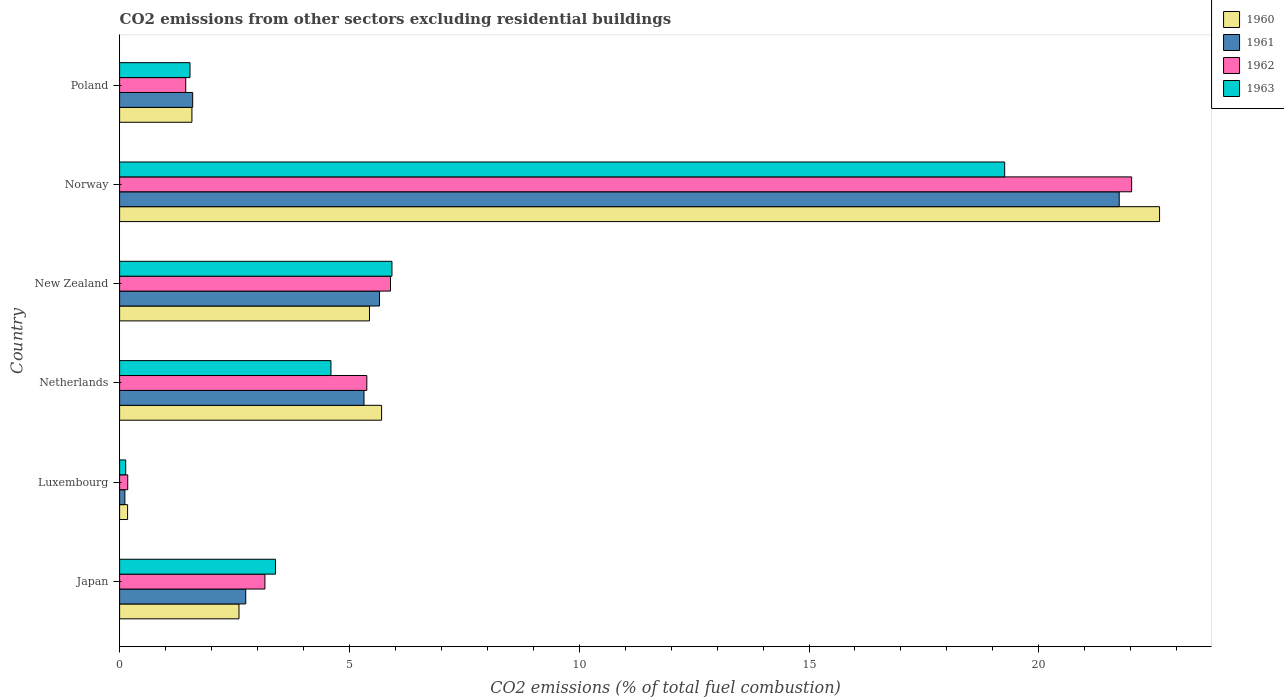Are the number of bars per tick equal to the number of legend labels?
Keep it short and to the point. Yes. How many bars are there on the 3rd tick from the bottom?
Your answer should be very brief. 4. What is the label of the 3rd group of bars from the top?
Ensure brevity in your answer.  New Zealand. What is the total CO2 emitted in 1962 in Japan?
Provide a succinct answer. 3.16. Across all countries, what is the maximum total CO2 emitted in 1963?
Your answer should be compact. 19.26. Across all countries, what is the minimum total CO2 emitted in 1960?
Give a very brief answer. 0.17. In which country was the total CO2 emitted in 1961 minimum?
Make the answer very short. Luxembourg. What is the total total CO2 emitted in 1963 in the graph?
Provide a succinct answer. 34.84. What is the difference between the total CO2 emitted in 1962 in New Zealand and that in Poland?
Make the answer very short. 4.45. What is the difference between the total CO2 emitted in 1961 in Poland and the total CO2 emitted in 1960 in Norway?
Offer a very short reply. -21.04. What is the average total CO2 emitted in 1961 per country?
Provide a succinct answer. 6.2. What is the difference between the total CO2 emitted in 1962 and total CO2 emitted in 1961 in Netherlands?
Offer a very short reply. 0.06. What is the ratio of the total CO2 emitted in 1963 in Japan to that in Netherlands?
Ensure brevity in your answer.  0.74. What is the difference between the highest and the second highest total CO2 emitted in 1962?
Provide a succinct answer. 16.13. What is the difference between the highest and the lowest total CO2 emitted in 1963?
Make the answer very short. 19.12. Is it the case that in every country, the sum of the total CO2 emitted in 1962 and total CO2 emitted in 1961 is greater than the sum of total CO2 emitted in 1960 and total CO2 emitted in 1963?
Give a very brief answer. No. What does the 4th bar from the top in Japan represents?
Keep it short and to the point. 1960. What does the 1st bar from the bottom in Norway represents?
Your answer should be compact. 1960. Is it the case that in every country, the sum of the total CO2 emitted in 1960 and total CO2 emitted in 1962 is greater than the total CO2 emitted in 1963?
Give a very brief answer. Yes. Are all the bars in the graph horizontal?
Provide a succinct answer. Yes. How many countries are there in the graph?
Offer a terse response. 6. What is the difference between two consecutive major ticks on the X-axis?
Offer a very short reply. 5. Does the graph contain any zero values?
Provide a short and direct response. No. How many legend labels are there?
Keep it short and to the point. 4. What is the title of the graph?
Offer a very short reply. CO2 emissions from other sectors excluding residential buildings. Does "1976" appear as one of the legend labels in the graph?
Make the answer very short. No. What is the label or title of the X-axis?
Keep it short and to the point. CO2 emissions (% of total fuel combustion). What is the label or title of the Y-axis?
Give a very brief answer. Country. What is the CO2 emissions (% of total fuel combustion) of 1960 in Japan?
Offer a terse response. 2.6. What is the CO2 emissions (% of total fuel combustion) in 1961 in Japan?
Keep it short and to the point. 2.74. What is the CO2 emissions (% of total fuel combustion) in 1962 in Japan?
Provide a short and direct response. 3.16. What is the CO2 emissions (% of total fuel combustion) in 1963 in Japan?
Make the answer very short. 3.39. What is the CO2 emissions (% of total fuel combustion) in 1960 in Luxembourg?
Provide a succinct answer. 0.17. What is the CO2 emissions (% of total fuel combustion) in 1961 in Luxembourg?
Offer a terse response. 0.11. What is the CO2 emissions (% of total fuel combustion) of 1962 in Luxembourg?
Offer a terse response. 0.18. What is the CO2 emissions (% of total fuel combustion) in 1963 in Luxembourg?
Offer a terse response. 0.13. What is the CO2 emissions (% of total fuel combustion) in 1960 in Netherlands?
Provide a short and direct response. 5.7. What is the CO2 emissions (% of total fuel combustion) of 1961 in Netherlands?
Your answer should be compact. 5.32. What is the CO2 emissions (% of total fuel combustion) of 1962 in Netherlands?
Ensure brevity in your answer.  5.38. What is the CO2 emissions (% of total fuel combustion) of 1963 in Netherlands?
Ensure brevity in your answer.  4.6. What is the CO2 emissions (% of total fuel combustion) in 1960 in New Zealand?
Provide a succinct answer. 5.44. What is the CO2 emissions (% of total fuel combustion) in 1961 in New Zealand?
Offer a very short reply. 5.66. What is the CO2 emissions (% of total fuel combustion) of 1962 in New Zealand?
Provide a succinct answer. 5.89. What is the CO2 emissions (% of total fuel combustion) in 1963 in New Zealand?
Give a very brief answer. 5.93. What is the CO2 emissions (% of total fuel combustion) of 1960 in Norway?
Give a very brief answer. 22.63. What is the CO2 emissions (% of total fuel combustion) of 1961 in Norway?
Provide a succinct answer. 21.75. What is the CO2 emissions (% of total fuel combustion) of 1962 in Norway?
Make the answer very short. 22.02. What is the CO2 emissions (% of total fuel combustion) in 1963 in Norway?
Your answer should be very brief. 19.26. What is the CO2 emissions (% of total fuel combustion) of 1960 in Poland?
Your answer should be compact. 1.57. What is the CO2 emissions (% of total fuel combustion) in 1961 in Poland?
Offer a very short reply. 1.59. What is the CO2 emissions (% of total fuel combustion) of 1962 in Poland?
Make the answer very short. 1.44. What is the CO2 emissions (% of total fuel combustion) in 1963 in Poland?
Provide a succinct answer. 1.53. Across all countries, what is the maximum CO2 emissions (% of total fuel combustion) of 1960?
Give a very brief answer. 22.63. Across all countries, what is the maximum CO2 emissions (% of total fuel combustion) of 1961?
Ensure brevity in your answer.  21.75. Across all countries, what is the maximum CO2 emissions (% of total fuel combustion) in 1962?
Ensure brevity in your answer.  22.02. Across all countries, what is the maximum CO2 emissions (% of total fuel combustion) of 1963?
Make the answer very short. 19.26. Across all countries, what is the minimum CO2 emissions (% of total fuel combustion) in 1960?
Offer a terse response. 0.17. Across all countries, what is the minimum CO2 emissions (% of total fuel combustion) in 1961?
Offer a very short reply. 0.11. Across all countries, what is the minimum CO2 emissions (% of total fuel combustion) of 1962?
Make the answer very short. 0.18. Across all countries, what is the minimum CO2 emissions (% of total fuel combustion) of 1963?
Your answer should be compact. 0.13. What is the total CO2 emissions (% of total fuel combustion) in 1960 in the graph?
Offer a terse response. 38.11. What is the total CO2 emissions (% of total fuel combustion) of 1961 in the graph?
Provide a succinct answer. 37.17. What is the total CO2 emissions (% of total fuel combustion) of 1962 in the graph?
Your answer should be very brief. 38.07. What is the total CO2 emissions (% of total fuel combustion) of 1963 in the graph?
Provide a succinct answer. 34.84. What is the difference between the CO2 emissions (% of total fuel combustion) of 1960 in Japan and that in Luxembourg?
Provide a succinct answer. 2.42. What is the difference between the CO2 emissions (% of total fuel combustion) of 1961 in Japan and that in Luxembourg?
Your answer should be compact. 2.63. What is the difference between the CO2 emissions (% of total fuel combustion) of 1962 in Japan and that in Luxembourg?
Provide a succinct answer. 2.98. What is the difference between the CO2 emissions (% of total fuel combustion) of 1963 in Japan and that in Luxembourg?
Provide a short and direct response. 3.26. What is the difference between the CO2 emissions (% of total fuel combustion) in 1960 in Japan and that in Netherlands?
Your response must be concise. -3.1. What is the difference between the CO2 emissions (% of total fuel combustion) of 1961 in Japan and that in Netherlands?
Make the answer very short. -2.57. What is the difference between the CO2 emissions (% of total fuel combustion) in 1962 in Japan and that in Netherlands?
Your response must be concise. -2.22. What is the difference between the CO2 emissions (% of total fuel combustion) in 1963 in Japan and that in Netherlands?
Your answer should be very brief. -1.21. What is the difference between the CO2 emissions (% of total fuel combustion) of 1960 in Japan and that in New Zealand?
Ensure brevity in your answer.  -2.84. What is the difference between the CO2 emissions (% of total fuel combustion) in 1961 in Japan and that in New Zealand?
Your answer should be very brief. -2.91. What is the difference between the CO2 emissions (% of total fuel combustion) in 1962 in Japan and that in New Zealand?
Provide a short and direct response. -2.73. What is the difference between the CO2 emissions (% of total fuel combustion) in 1963 in Japan and that in New Zealand?
Your response must be concise. -2.53. What is the difference between the CO2 emissions (% of total fuel combustion) in 1960 in Japan and that in Norway?
Ensure brevity in your answer.  -20.03. What is the difference between the CO2 emissions (% of total fuel combustion) in 1961 in Japan and that in Norway?
Offer a very short reply. -19. What is the difference between the CO2 emissions (% of total fuel combustion) in 1962 in Japan and that in Norway?
Provide a succinct answer. -18.86. What is the difference between the CO2 emissions (% of total fuel combustion) of 1963 in Japan and that in Norway?
Make the answer very short. -15.87. What is the difference between the CO2 emissions (% of total fuel combustion) in 1960 in Japan and that in Poland?
Your answer should be very brief. 1.02. What is the difference between the CO2 emissions (% of total fuel combustion) of 1961 in Japan and that in Poland?
Offer a very short reply. 1.15. What is the difference between the CO2 emissions (% of total fuel combustion) in 1962 in Japan and that in Poland?
Offer a terse response. 1.72. What is the difference between the CO2 emissions (% of total fuel combustion) of 1963 in Japan and that in Poland?
Ensure brevity in your answer.  1.86. What is the difference between the CO2 emissions (% of total fuel combustion) in 1960 in Luxembourg and that in Netherlands?
Keep it short and to the point. -5.53. What is the difference between the CO2 emissions (% of total fuel combustion) of 1961 in Luxembourg and that in Netherlands?
Offer a very short reply. -5.2. What is the difference between the CO2 emissions (% of total fuel combustion) of 1962 in Luxembourg and that in Netherlands?
Offer a very short reply. -5.2. What is the difference between the CO2 emissions (% of total fuel combustion) of 1963 in Luxembourg and that in Netherlands?
Your answer should be compact. -4.47. What is the difference between the CO2 emissions (% of total fuel combustion) of 1960 in Luxembourg and that in New Zealand?
Make the answer very short. -5.26. What is the difference between the CO2 emissions (% of total fuel combustion) in 1961 in Luxembourg and that in New Zealand?
Offer a terse response. -5.54. What is the difference between the CO2 emissions (% of total fuel combustion) in 1962 in Luxembourg and that in New Zealand?
Offer a terse response. -5.72. What is the difference between the CO2 emissions (% of total fuel combustion) of 1963 in Luxembourg and that in New Zealand?
Give a very brief answer. -5.79. What is the difference between the CO2 emissions (% of total fuel combustion) of 1960 in Luxembourg and that in Norway?
Provide a short and direct response. -22.45. What is the difference between the CO2 emissions (% of total fuel combustion) in 1961 in Luxembourg and that in Norway?
Give a very brief answer. -21.63. What is the difference between the CO2 emissions (% of total fuel combustion) in 1962 in Luxembourg and that in Norway?
Offer a very short reply. -21.84. What is the difference between the CO2 emissions (% of total fuel combustion) of 1963 in Luxembourg and that in Norway?
Offer a terse response. -19.12. What is the difference between the CO2 emissions (% of total fuel combustion) of 1960 in Luxembourg and that in Poland?
Your answer should be compact. -1.4. What is the difference between the CO2 emissions (% of total fuel combustion) in 1961 in Luxembourg and that in Poland?
Your answer should be compact. -1.48. What is the difference between the CO2 emissions (% of total fuel combustion) in 1962 in Luxembourg and that in Poland?
Your response must be concise. -1.26. What is the difference between the CO2 emissions (% of total fuel combustion) of 1963 in Luxembourg and that in Poland?
Give a very brief answer. -1.4. What is the difference between the CO2 emissions (% of total fuel combustion) in 1960 in Netherlands and that in New Zealand?
Offer a terse response. 0.26. What is the difference between the CO2 emissions (% of total fuel combustion) in 1961 in Netherlands and that in New Zealand?
Offer a very short reply. -0.34. What is the difference between the CO2 emissions (% of total fuel combustion) of 1962 in Netherlands and that in New Zealand?
Your answer should be compact. -0.52. What is the difference between the CO2 emissions (% of total fuel combustion) in 1963 in Netherlands and that in New Zealand?
Provide a short and direct response. -1.33. What is the difference between the CO2 emissions (% of total fuel combustion) of 1960 in Netherlands and that in Norway?
Provide a short and direct response. -16.93. What is the difference between the CO2 emissions (% of total fuel combustion) of 1961 in Netherlands and that in Norway?
Your answer should be compact. -16.43. What is the difference between the CO2 emissions (% of total fuel combustion) of 1962 in Netherlands and that in Norway?
Keep it short and to the point. -16.64. What is the difference between the CO2 emissions (% of total fuel combustion) of 1963 in Netherlands and that in Norway?
Give a very brief answer. -14.66. What is the difference between the CO2 emissions (% of total fuel combustion) of 1960 in Netherlands and that in Poland?
Make the answer very short. 4.13. What is the difference between the CO2 emissions (% of total fuel combustion) of 1961 in Netherlands and that in Poland?
Give a very brief answer. 3.73. What is the difference between the CO2 emissions (% of total fuel combustion) of 1962 in Netherlands and that in Poland?
Make the answer very short. 3.94. What is the difference between the CO2 emissions (% of total fuel combustion) in 1963 in Netherlands and that in Poland?
Make the answer very short. 3.07. What is the difference between the CO2 emissions (% of total fuel combustion) of 1960 in New Zealand and that in Norway?
Ensure brevity in your answer.  -17.19. What is the difference between the CO2 emissions (% of total fuel combustion) of 1961 in New Zealand and that in Norway?
Your answer should be very brief. -16.09. What is the difference between the CO2 emissions (% of total fuel combustion) of 1962 in New Zealand and that in Norway?
Make the answer very short. -16.13. What is the difference between the CO2 emissions (% of total fuel combustion) of 1963 in New Zealand and that in Norway?
Ensure brevity in your answer.  -13.33. What is the difference between the CO2 emissions (% of total fuel combustion) of 1960 in New Zealand and that in Poland?
Your answer should be very brief. 3.86. What is the difference between the CO2 emissions (% of total fuel combustion) of 1961 in New Zealand and that in Poland?
Provide a succinct answer. 4.07. What is the difference between the CO2 emissions (% of total fuel combustion) of 1962 in New Zealand and that in Poland?
Your answer should be compact. 4.45. What is the difference between the CO2 emissions (% of total fuel combustion) of 1963 in New Zealand and that in Poland?
Your answer should be compact. 4.39. What is the difference between the CO2 emissions (% of total fuel combustion) of 1960 in Norway and that in Poland?
Provide a short and direct response. 21.05. What is the difference between the CO2 emissions (% of total fuel combustion) of 1961 in Norway and that in Poland?
Your answer should be very brief. 20.16. What is the difference between the CO2 emissions (% of total fuel combustion) of 1962 in Norway and that in Poland?
Provide a succinct answer. 20.58. What is the difference between the CO2 emissions (% of total fuel combustion) of 1963 in Norway and that in Poland?
Ensure brevity in your answer.  17.73. What is the difference between the CO2 emissions (% of total fuel combustion) of 1960 in Japan and the CO2 emissions (% of total fuel combustion) of 1961 in Luxembourg?
Provide a succinct answer. 2.48. What is the difference between the CO2 emissions (% of total fuel combustion) in 1960 in Japan and the CO2 emissions (% of total fuel combustion) in 1962 in Luxembourg?
Give a very brief answer. 2.42. What is the difference between the CO2 emissions (% of total fuel combustion) in 1960 in Japan and the CO2 emissions (% of total fuel combustion) in 1963 in Luxembourg?
Your answer should be very brief. 2.46. What is the difference between the CO2 emissions (% of total fuel combustion) in 1961 in Japan and the CO2 emissions (% of total fuel combustion) in 1962 in Luxembourg?
Offer a terse response. 2.57. What is the difference between the CO2 emissions (% of total fuel combustion) in 1961 in Japan and the CO2 emissions (% of total fuel combustion) in 1963 in Luxembourg?
Ensure brevity in your answer.  2.61. What is the difference between the CO2 emissions (% of total fuel combustion) in 1962 in Japan and the CO2 emissions (% of total fuel combustion) in 1963 in Luxembourg?
Ensure brevity in your answer.  3.03. What is the difference between the CO2 emissions (% of total fuel combustion) of 1960 in Japan and the CO2 emissions (% of total fuel combustion) of 1961 in Netherlands?
Give a very brief answer. -2.72. What is the difference between the CO2 emissions (% of total fuel combustion) in 1960 in Japan and the CO2 emissions (% of total fuel combustion) in 1962 in Netherlands?
Offer a very short reply. -2.78. What is the difference between the CO2 emissions (% of total fuel combustion) in 1960 in Japan and the CO2 emissions (% of total fuel combustion) in 1963 in Netherlands?
Provide a succinct answer. -2. What is the difference between the CO2 emissions (% of total fuel combustion) in 1961 in Japan and the CO2 emissions (% of total fuel combustion) in 1962 in Netherlands?
Your answer should be very brief. -2.63. What is the difference between the CO2 emissions (% of total fuel combustion) in 1961 in Japan and the CO2 emissions (% of total fuel combustion) in 1963 in Netherlands?
Ensure brevity in your answer.  -1.85. What is the difference between the CO2 emissions (% of total fuel combustion) of 1962 in Japan and the CO2 emissions (% of total fuel combustion) of 1963 in Netherlands?
Make the answer very short. -1.44. What is the difference between the CO2 emissions (% of total fuel combustion) of 1960 in Japan and the CO2 emissions (% of total fuel combustion) of 1961 in New Zealand?
Offer a terse response. -3.06. What is the difference between the CO2 emissions (% of total fuel combustion) in 1960 in Japan and the CO2 emissions (% of total fuel combustion) in 1962 in New Zealand?
Offer a very short reply. -3.3. What is the difference between the CO2 emissions (% of total fuel combustion) of 1960 in Japan and the CO2 emissions (% of total fuel combustion) of 1963 in New Zealand?
Your answer should be very brief. -3.33. What is the difference between the CO2 emissions (% of total fuel combustion) in 1961 in Japan and the CO2 emissions (% of total fuel combustion) in 1962 in New Zealand?
Ensure brevity in your answer.  -3.15. What is the difference between the CO2 emissions (% of total fuel combustion) in 1961 in Japan and the CO2 emissions (% of total fuel combustion) in 1963 in New Zealand?
Provide a succinct answer. -3.18. What is the difference between the CO2 emissions (% of total fuel combustion) in 1962 in Japan and the CO2 emissions (% of total fuel combustion) in 1963 in New Zealand?
Keep it short and to the point. -2.76. What is the difference between the CO2 emissions (% of total fuel combustion) of 1960 in Japan and the CO2 emissions (% of total fuel combustion) of 1961 in Norway?
Provide a succinct answer. -19.15. What is the difference between the CO2 emissions (% of total fuel combustion) of 1960 in Japan and the CO2 emissions (% of total fuel combustion) of 1962 in Norway?
Give a very brief answer. -19.42. What is the difference between the CO2 emissions (% of total fuel combustion) in 1960 in Japan and the CO2 emissions (% of total fuel combustion) in 1963 in Norway?
Your answer should be compact. -16.66. What is the difference between the CO2 emissions (% of total fuel combustion) of 1961 in Japan and the CO2 emissions (% of total fuel combustion) of 1962 in Norway?
Give a very brief answer. -19.28. What is the difference between the CO2 emissions (% of total fuel combustion) in 1961 in Japan and the CO2 emissions (% of total fuel combustion) in 1963 in Norway?
Your answer should be compact. -16.51. What is the difference between the CO2 emissions (% of total fuel combustion) in 1962 in Japan and the CO2 emissions (% of total fuel combustion) in 1963 in Norway?
Provide a succinct answer. -16.1. What is the difference between the CO2 emissions (% of total fuel combustion) of 1960 in Japan and the CO2 emissions (% of total fuel combustion) of 1961 in Poland?
Keep it short and to the point. 1.01. What is the difference between the CO2 emissions (% of total fuel combustion) of 1960 in Japan and the CO2 emissions (% of total fuel combustion) of 1962 in Poland?
Ensure brevity in your answer.  1.16. What is the difference between the CO2 emissions (% of total fuel combustion) in 1960 in Japan and the CO2 emissions (% of total fuel combustion) in 1963 in Poland?
Your response must be concise. 1.07. What is the difference between the CO2 emissions (% of total fuel combustion) of 1961 in Japan and the CO2 emissions (% of total fuel combustion) of 1962 in Poland?
Your answer should be very brief. 1.31. What is the difference between the CO2 emissions (% of total fuel combustion) of 1961 in Japan and the CO2 emissions (% of total fuel combustion) of 1963 in Poland?
Your answer should be compact. 1.21. What is the difference between the CO2 emissions (% of total fuel combustion) in 1962 in Japan and the CO2 emissions (% of total fuel combustion) in 1963 in Poland?
Make the answer very short. 1.63. What is the difference between the CO2 emissions (% of total fuel combustion) of 1960 in Luxembourg and the CO2 emissions (% of total fuel combustion) of 1961 in Netherlands?
Ensure brevity in your answer.  -5.14. What is the difference between the CO2 emissions (% of total fuel combustion) in 1960 in Luxembourg and the CO2 emissions (% of total fuel combustion) in 1962 in Netherlands?
Give a very brief answer. -5.2. What is the difference between the CO2 emissions (% of total fuel combustion) of 1960 in Luxembourg and the CO2 emissions (% of total fuel combustion) of 1963 in Netherlands?
Ensure brevity in your answer.  -4.42. What is the difference between the CO2 emissions (% of total fuel combustion) of 1961 in Luxembourg and the CO2 emissions (% of total fuel combustion) of 1962 in Netherlands?
Your answer should be compact. -5.26. What is the difference between the CO2 emissions (% of total fuel combustion) in 1961 in Luxembourg and the CO2 emissions (% of total fuel combustion) in 1963 in Netherlands?
Offer a terse response. -4.48. What is the difference between the CO2 emissions (% of total fuel combustion) of 1962 in Luxembourg and the CO2 emissions (% of total fuel combustion) of 1963 in Netherlands?
Give a very brief answer. -4.42. What is the difference between the CO2 emissions (% of total fuel combustion) of 1960 in Luxembourg and the CO2 emissions (% of total fuel combustion) of 1961 in New Zealand?
Your answer should be compact. -5.48. What is the difference between the CO2 emissions (% of total fuel combustion) of 1960 in Luxembourg and the CO2 emissions (% of total fuel combustion) of 1962 in New Zealand?
Your answer should be compact. -5.72. What is the difference between the CO2 emissions (% of total fuel combustion) of 1960 in Luxembourg and the CO2 emissions (% of total fuel combustion) of 1963 in New Zealand?
Offer a terse response. -5.75. What is the difference between the CO2 emissions (% of total fuel combustion) in 1961 in Luxembourg and the CO2 emissions (% of total fuel combustion) in 1962 in New Zealand?
Make the answer very short. -5.78. What is the difference between the CO2 emissions (% of total fuel combustion) in 1961 in Luxembourg and the CO2 emissions (% of total fuel combustion) in 1963 in New Zealand?
Your response must be concise. -5.81. What is the difference between the CO2 emissions (% of total fuel combustion) of 1962 in Luxembourg and the CO2 emissions (% of total fuel combustion) of 1963 in New Zealand?
Your answer should be compact. -5.75. What is the difference between the CO2 emissions (% of total fuel combustion) of 1960 in Luxembourg and the CO2 emissions (% of total fuel combustion) of 1961 in Norway?
Make the answer very short. -21.58. What is the difference between the CO2 emissions (% of total fuel combustion) in 1960 in Luxembourg and the CO2 emissions (% of total fuel combustion) in 1962 in Norway?
Offer a very short reply. -21.85. What is the difference between the CO2 emissions (% of total fuel combustion) in 1960 in Luxembourg and the CO2 emissions (% of total fuel combustion) in 1963 in Norway?
Your response must be concise. -19.08. What is the difference between the CO2 emissions (% of total fuel combustion) of 1961 in Luxembourg and the CO2 emissions (% of total fuel combustion) of 1962 in Norway?
Keep it short and to the point. -21.91. What is the difference between the CO2 emissions (% of total fuel combustion) in 1961 in Luxembourg and the CO2 emissions (% of total fuel combustion) in 1963 in Norway?
Offer a very short reply. -19.14. What is the difference between the CO2 emissions (% of total fuel combustion) in 1962 in Luxembourg and the CO2 emissions (% of total fuel combustion) in 1963 in Norway?
Your answer should be compact. -19.08. What is the difference between the CO2 emissions (% of total fuel combustion) of 1960 in Luxembourg and the CO2 emissions (% of total fuel combustion) of 1961 in Poland?
Offer a very short reply. -1.42. What is the difference between the CO2 emissions (% of total fuel combustion) of 1960 in Luxembourg and the CO2 emissions (% of total fuel combustion) of 1962 in Poland?
Your answer should be very brief. -1.27. What is the difference between the CO2 emissions (% of total fuel combustion) in 1960 in Luxembourg and the CO2 emissions (% of total fuel combustion) in 1963 in Poland?
Give a very brief answer. -1.36. What is the difference between the CO2 emissions (% of total fuel combustion) of 1961 in Luxembourg and the CO2 emissions (% of total fuel combustion) of 1962 in Poland?
Ensure brevity in your answer.  -1.32. What is the difference between the CO2 emissions (% of total fuel combustion) of 1961 in Luxembourg and the CO2 emissions (% of total fuel combustion) of 1963 in Poland?
Make the answer very short. -1.42. What is the difference between the CO2 emissions (% of total fuel combustion) of 1962 in Luxembourg and the CO2 emissions (% of total fuel combustion) of 1963 in Poland?
Offer a very short reply. -1.35. What is the difference between the CO2 emissions (% of total fuel combustion) of 1960 in Netherlands and the CO2 emissions (% of total fuel combustion) of 1961 in New Zealand?
Make the answer very short. 0.05. What is the difference between the CO2 emissions (% of total fuel combustion) in 1960 in Netherlands and the CO2 emissions (% of total fuel combustion) in 1962 in New Zealand?
Give a very brief answer. -0.19. What is the difference between the CO2 emissions (% of total fuel combustion) of 1960 in Netherlands and the CO2 emissions (% of total fuel combustion) of 1963 in New Zealand?
Your answer should be very brief. -0.23. What is the difference between the CO2 emissions (% of total fuel combustion) in 1961 in Netherlands and the CO2 emissions (% of total fuel combustion) in 1962 in New Zealand?
Offer a terse response. -0.58. What is the difference between the CO2 emissions (% of total fuel combustion) of 1961 in Netherlands and the CO2 emissions (% of total fuel combustion) of 1963 in New Zealand?
Give a very brief answer. -0.61. What is the difference between the CO2 emissions (% of total fuel combustion) in 1962 in Netherlands and the CO2 emissions (% of total fuel combustion) in 1963 in New Zealand?
Ensure brevity in your answer.  -0.55. What is the difference between the CO2 emissions (% of total fuel combustion) in 1960 in Netherlands and the CO2 emissions (% of total fuel combustion) in 1961 in Norway?
Your response must be concise. -16.05. What is the difference between the CO2 emissions (% of total fuel combustion) of 1960 in Netherlands and the CO2 emissions (% of total fuel combustion) of 1962 in Norway?
Ensure brevity in your answer.  -16.32. What is the difference between the CO2 emissions (% of total fuel combustion) of 1960 in Netherlands and the CO2 emissions (% of total fuel combustion) of 1963 in Norway?
Provide a short and direct response. -13.56. What is the difference between the CO2 emissions (% of total fuel combustion) of 1961 in Netherlands and the CO2 emissions (% of total fuel combustion) of 1962 in Norway?
Provide a succinct answer. -16.7. What is the difference between the CO2 emissions (% of total fuel combustion) of 1961 in Netherlands and the CO2 emissions (% of total fuel combustion) of 1963 in Norway?
Provide a succinct answer. -13.94. What is the difference between the CO2 emissions (% of total fuel combustion) of 1962 in Netherlands and the CO2 emissions (% of total fuel combustion) of 1963 in Norway?
Make the answer very short. -13.88. What is the difference between the CO2 emissions (% of total fuel combustion) in 1960 in Netherlands and the CO2 emissions (% of total fuel combustion) in 1961 in Poland?
Offer a very short reply. 4.11. What is the difference between the CO2 emissions (% of total fuel combustion) in 1960 in Netherlands and the CO2 emissions (% of total fuel combustion) in 1962 in Poland?
Give a very brief answer. 4.26. What is the difference between the CO2 emissions (% of total fuel combustion) of 1960 in Netherlands and the CO2 emissions (% of total fuel combustion) of 1963 in Poland?
Your response must be concise. 4.17. What is the difference between the CO2 emissions (% of total fuel combustion) of 1961 in Netherlands and the CO2 emissions (% of total fuel combustion) of 1962 in Poland?
Your answer should be compact. 3.88. What is the difference between the CO2 emissions (% of total fuel combustion) of 1961 in Netherlands and the CO2 emissions (% of total fuel combustion) of 1963 in Poland?
Keep it short and to the point. 3.79. What is the difference between the CO2 emissions (% of total fuel combustion) of 1962 in Netherlands and the CO2 emissions (% of total fuel combustion) of 1963 in Poland?
Your answer should be compact. 3.85. What is the difference between the CO2 emissions (% of total fuel combustion) of 1960 in New Zealand and the CO2 emissions (% of total fuel combustion) of 1961 in Norway?
Keep it short and to the point. -16.31. What is the difference between the CO2 emissions (% of total fuel combustion) of 1960 in New Zealand and the CO2 emissions (% of total fuel combustion) of 1962 in Norway?
Ensure brevity in your answer.  -16.58. What is the difference between the CO2 emissions (% of total fuel combustion) in 1960 in New Zealand and the CO2 emissions (% of total fuel combustion) in 1963 in Norway?
Your answer should be very brief. -13.82. What is the difference between the CO2 emissions (% of total fuel combustion) of 1961 in New Zealand and the CO2 emissions (% of total fuel combustion) of 1962 in Norway?
Ensure brevity in your answer.  -16.36. What is the difference between the CO2 emissions (% of total fuel combustion) of 1961 in New Zealand and the CO2 emissions (% of total fuel combustion) of 1963 in Norway?
Keep it short and to the point. -13.6. What is the difference between the CO2 emissions (% of total fuel combustion) of 1962 in New Zealand and the CO2 emissions (% of total fuel combustion) of 1963 in Norway?
Your response must be concise. -13.36. What is the difference between the CO2 emissions (% of total fuel combustion) of 1960 in New Zealand and the CO2 emissions (% of total fuel combustion) of 1961 in Poland?
Provide a succinct answer. 3.85. What is the difference between the CO2 emissions (% of total fuel combustion) of 1960 in New Zealand and the CO2 emissions (% of total fuel combustion) of 1962 in Poland?
Your answer should be compact. 4. What is the difference between the CO2 emissions (% of total fuel combustion) in 1960 in New Zealand and the CO2 emissions (% of total fuel combustion) in 1963 in Poland?
Provide a succinct answer. 3.91. What is the difference between the CO2 emissions (% of total fuel combustion) in 1961 in New Zealand and the CO2 emissions (% of total fuel combustion) in 1962 in Poland?
Offer a terse response. 4.22. What is the difference between the CO2 emissions (% of total fuel combustion) of 1961 in New Zealand and the CO2 emissions (% of total fuel combustion) of 1963 in Poland?
Provide a short and direct response. 4.12. What is the difference between the CO2 emissions (% of total fuel combustion) of 1962 in New Zealand and the CO2 emissions (% of total fuel combustion) of 1963 in Poland?
Give a very brief answer. 4.36. What is the difference between the CO2 emissions (% of total fuel combustion) in 1960 in Norway and the CO2 emissions (% of total fuel combustion) in 1961 in Poland?
Offer a terse response. 21.04. What is the difference between the CO2 emissions (% of total fuel combustion) in 1960 in Norway and the CO2 emissions (% of total fuel combustion) in 1962 in Poland?
Offer a terse response. 21.19. What is the difference between the CO2 emissions (% of total fuel combustion) in 1960 in Norway and the CO2 emissions (% of total fuel combustion) in 1963 in Poland?
Give a very brief answer. 21.1. What is the difference between the CO2 emissions (% of total fuel combustion) of 1961 in Norway and the CO2 emissions (% of total fuel combustion) of 1962 in Poland?
Make the answer very short. 20.31. What is the difference between the CO2 emissions (% of total fuel combustion) in 1961 in Norway and the CO2 emissions (% of total fuel combustion) in 1963 in Poland?
Your response must be concise. 20.22. What is the difference between the CO2 emissions (% of total fuel combustion) of 1962 in Norway and the CO2 emissions (% of total fuel combustion) of 1963 in Poland?
Your answer should be compact. 20.49. What is the average CO2 emissions (% of total fuel combustion) in 1960 per country?
Keep it short and to the point. 6.35. What is the average CO2 emissions (% of total fuel combustion) in 1961 per country?
Provide a succinct answer. 6.2. What is the average CO2 emissions (% of total fuel combustion) of 1962 per country?
Offer a very short reply. 6.35. What is the average CO2 emissions (% of total fuel combustion) in 1963 per country?
Your answer should be compact. 5.81. What is the difference between the CO2 emissions (% of total fuel combustion) of 1960 and CO2 emissions (% of total fuel combustion) of 1961 in Japan?
Keep it short and to the point. -0.15. What is the difference between the CO2 emissions (% of total fuel combustion) in 1960 and CO2 emissions (% of total fuel combustion) in 1962 in Japan?
Provide a short and direct response. -0.56. What is the difference between the CO2 emissions (% of total fuel combustion) of 1960 and CO2 emissions (% of total fuel combustion) of 1963 in Japan?
Ensure brevity in your answer.  -0.79. What is the difference between the CO2 emissions (% of total fuel combustion) of 1961 and CO2 emissions (% of total fuel combustion) of 1962 in Japan?
Keep it short and to the point. -0.42. What is the difference between the CO2 emissions (% of total fuel combustion) of 1961 and CO2 emissions (% of total fuel combustion) of 1963 in Japan?
Make the answer very short. -0.65. What is the difference between the CO2 emissions (% of total fuel combustion) in 1962 and CO2 emissions (% of total fuel combustion) in 1963 in Japan?
Provide a succinct answer. -0.23. What is the difference between the CO2 emissions (% of total fuel combustion) in 1960 and CO2 emissions (% of total fuel combustion) in 1961 in Luxembourg?
Provide a short and direct response. 0.06. What is the difference between the CO2 emissions (% of total fuel combustion) of 1960 and CO2 emissions (% of total fuel combustion) of 1962 in Luxembourg?
Provide a short and direct response. -0. What is the difference between the CO2 emissions (% of total fuel combustion) of 1960 and CO2 emissions (% of total fuel combustion) of 1963 in Luxembourg?
Offer a terse response. 0.04. What is the difference between the CO2 emissions (% of total fuel combustion) of 1961 and CO2 emissions (% of total fuel combustion) of 1962 in Luxembourg?
Provide a short and direct response. -0.06. What is the difference between the CO2 emissions (% of total fuel combustion) of 1961 and CO2 emissions (% of total fuel combustion) of 1963 in Luxembourg?
Your response must be concise. -0.02. What is the difference between the CO2 emissions (% of total fuel combustion) in 1962 and CO2 emissions (% of total fuel combustion) in 1963 in Luxembourg?
Ensure brevity in your answer.  0.04. What is the difference between the CO2 emissions (% of total fuel combustion) of 1960 and CO2 emissions (% of total fuel combustion) of 1961 in Netherlands?
Give a very brief answer. 0.38. What is the difference between the CO2 emissions (% of total fuel combustion) of 1960 and CO2 emissions (% of total fuel combustion) of 1962 in Netherlands?
Offer a terse response. 0.32. What is the difference between the CO2 emissions (% of total fuel combustion) in 1960 and CO2 emissions (% of total fuel combustion) in 1963 in Netherlands?
Provide a short and direct response. 1.1. What is the difference between the CO2 emissions (% of total fuel combustion) in 1961 and CO2 emissions (% of total fuel combustion) in 1962 in Netherlands?
Provide a succinct answer. -0.06. What is the difference between the CO2 emissions (% of total fuel combustion) in 1961 and CO2 emissions (% of total fuel combustion) in 1963 in Netherlands?
Keep it short and to the point. 0.72. What is the difference between the CO2 emissions (% of total fuel combustion) of 1962 and CO2 emissions (% of total fuel combustion) of 1963 in Netherlands?
Your response must be concise. 0.78. What is the difference between the CO2 emissions (% of total fuel combustion) in 1960 and CO2 emissions (% of total fuel combustion) in 1961 in New Zealand?
Give a very brief answer. -0.22. What is the difference between the CO2 emissions (% of total fuel combustion) in 1960 and CO2 emissions (% of total fuel combustion) in 1962 in New Zealand?
Offer a terse response. -0.46. What is the difference between the CO2 emissions (% of total fuel combustion) of 1960 and CO2 emissions (% of total fuel combustion) of 1963 in New Zealand?
Provide a succinct answer. -0.49. What is the difference between the CO2 emissions (% of total fuel combustion) of 1961 and CO2 emissions (% of total fuel combustion) of 1962 in New Zealand?
Provide a short and direct response. -0.24. What is the difference between the CO2 emissions (% of total fuel combustion) of 1961 and CO2 emissions (% of total fuel combustion) of 1963 in New Zealand?
Offer a terse response. -0.27. What is the difference between the CO2 emissions (% of total fuel combustion) of 1962 and CO2 emissions (% of total fuel combustion) of 1963 in New Zealand?
Offer a terse response. -0.03. What is the difference between the CO2 emissions (% of total fuel combustion) of 1960 and CO2 emissions (% of total fuel combustion) of 1961 in Norway?
Keep it short and to the point. 0.88. What is the difference between the CO2 emissions (% of total fuel combustion) in 1960 and CO2 emissions (% of total fuel combustion) in 1962 in Norway?
Provide a short and direct response. 0.61. What is the difference between the CO2 emissions (% of total fuel combustion) in 1960 and CO2 emissions (% of total fuel combustion) in 1963 in Norway?
Give a very brief answer. 3.37. What is the difference between the CO2 emissions (% of total fuel combustion) in 1961 and CO2 emissions (% of total fuel combustion) in 1962 in Norway?
Make the answer very short. -0.27. What is the difference between the CO2 emissions (% of total fuel combustion) in 1961 and CO2 emissions (% of total fuel combustion) in 1963 in Norway?
Offer a terse response. 2.49. What is the difference between the CO2 emissions (% of total fuel combustion) in 1962 and CO2 emissions (% of total fuel combustion) in 1963 in Norway?
Make the answer very short. 2.76. What is the difference between the CO2 emissions (% of total fuel combustion) of 1960 and CO2 emissions (% of total fuel combustion) of 1961 in Poland?
Your answer should be very brief. -0.02. What is the difference between the CO2 emissions (% of total fuel combustion) of 1960 and CO2 emissions (% of total fuel combustion) of 1962 in Poland?
Your response must be concise. 0.13. What is the difference between the CO2 emissions (% of total fuel combustion) in 1960 and CO2 emissions (% of total fuel combustion) in 1963 in Poland?
Your answer should be very brief. 0.04. What is the difference between the CO2 emissions (% of total fuel combustion) in 1961 and CO2 emissions (% of total fuel combustion) in 1962 in Poland?
Ensure brevity in your answer.  0.15. What is the difference between the CO2 emissions (% of total fuel combustion) of 1961 and CO2 emissions (% of total fuel combustion) of 1963 in Poland?
Ensure brevity in your answer.  0.06. What is the difference between the CO2 emissions (% of total fuel combustion) in 1962 and CO2 emissions (% of total fuel combustion) in 1963 in Poland?
Your response must be concise. -0.09. What is the ratio of the CO2 emissions (% of total fuel combustion) in 1960 in Japan to that in Luxembourg?
Your response must be concise. 14.93. What is the ratio of the CO2 emissions (% of total fuel combustion) of 1961 in Japan to that in Luxembourg?
Ensure brevity in your answer.  23.95. What is the ratio of the CO2 emissions (% of total fuel combustion) of 1962 in Japan to that in Luxembourg?
Your answer should be very brief. 17.85. What is the ratio of the CO2 emissions (% of total fuel combustion) in 1963 in Japan to that in Luxembourg?
Give a very brief answer. 25.57. What is the ratio of the CO2 emissions (% of total fuel combustion) of 1960 in Japan to that in Netherlands?
Make the answer very short. 0.46. What is the ratio of the CO2 emissions (% of total fuel combustion) of 1961 in Japan to that in Netherlands?
Provide a succinct answer. 0.52. What is the ratio of the CO2 emissions (% of total fuel combustion) in 1962 in Japan to that in Netherlands?
Give a very brief answer. 0.59. What is the ratio of the CO2 emissions (% of total fuel combustion) of 1963 in Japan to that in Netherlands?
Offer a very short reply. 0.74. What is the ratio of the CO2 emissions (% of total fuel combustion) of 1960 in Japan to that in New Zealand?
Your response must be concise. 0.48. What is the ratio of the CO2 emissions (% of total fuel combustion) of 1961 in Japan to that in New Zealand?
Provide a short and direct response. 0.49. What is the ratio of the CO2 emissions (% of total fuel combustion) in 1962 in Japan to that in New Zealand?
Provide a succinct answer. 0.54. What is the ratio of the CO2 emissions (% of total fuel combustion) of 1963 in Japan to that in New Zealand?
Keep it short and to the point. 0.57. What is the ratio of the CO2 emissions (% of total fuel combustion) of 1960 in Japan to that in Norway?
Give a very brief answer. 0.11. What is the ratio of the CO2 emissions (% of total fuel combustion) of 1961 in Japan to that in Norway?
Ensure brevity in your answer.  0.13. What is the ratio of the CO2 emissions (% of total fuel combustion) in 1962 in Japan to that in Norway?
Your answer should be compact. 0.14. What is the ratio of the CO2 emissions (% of total fuel combustion) in 1963 in Japan to that in Norway?
Your answer should be very brief. 0.18. What is the ratio of the CO2 emissions (% of total fuel combustion) of 1960 in Japan to that in Poland?
Offer a very short reply. 1.65. What is the ratio of the CO2 emissions (% of total fuel combustion) of 1961 in Japan to that in Poland?
Keep it short and to the point. 1.73. What is the ratio of the CO2 emissions (% of total fuel combustion) of 1962 in Japan to that in Poland?
Make the answer very short. 2.2. What is the ratio of the CO2 emissions (% of total fuel combustion) of 1963 in Japan to that in Poland?
Your answer should be compact. 2.21. What is the ratio of the CO2 emissions (% of total fuel combustion) of 1960 in Luxembourg to that in Netherlands?
Provide a short and direct response. 0.03. What is the ratio of the CO2 emissions (% of total fuel combustion) in 1961 in Luxembourg to that in Netherlands?
Keep it short and to the point. 0.02. What is the ratio of the CO2 emissions (% of total fuel combustion) of 1962 in Luxembourg to that in Netherlands?
Provide a short and direct response. 0.03. What is the ratio of the CO2 emissions (% of total fuel combustion) of 1963 in Luxembourg to that in Netherlands?
Provide a succinct answer. 0.03. What is the ratio of the CO2 emissions (% of total fuel combustion) of 1960 in Luxembourg to that in New Zealand?
Your response must be concise. 0.03. What is the ratio of the CO2 emissions (% of total fuel combustion) in 1961 in Luxembourg to that in New Zealand?
Your answer should be very brief. 0.02. What is the ratio of the CO2 emissions (% of total fuel combustion) of 1962 in Luxembourg to that in New Zealand?
Your answer should be compact. 0.03. What is the ratio of the CO2 emissions (% of total fuel combustion) in 1963 in Luxembourg to that in New Zealand?
Provide a short and direct response. 0.02. What is the ratio of the CO2 emissions (% of total fuel combustion) in 1960 in Luxembourg to that in Norway?
Offer a very short reply. 0.01. What is the ratio of the CO2 emissions (% of total fuel combustion) of 1961 in Luxembourg to that in Norway?
Give a very brief answer. 0.01. What is the ratio of the CO2 emissions (% of total fuel combustion) in 1962 in Luxembourg to that in Norway?
Provide a short and direct response. 0.01. What is the ratio of the CO2 emissions (% of total fuel combustion) in 1963 in Luxembourg to that in Norway?
Your response must be concise. 0.01. What is the ratio of the CO2 emissions (% of total fuel combustion) in 1960 in Luxembourg to that in Poland?
Provide a short and direct response. 0.11. What is the ratio of the CO2 emissions (% of total fuel combustion) of 1961 in Luxembourg to that in Poland?
Offer a very short reply. 0.07. What is the ratio of the CO2 emissions (% of total fuel combustion) in 1962 in Luxembourg to that in Poland?
Provide a short and direct response. 0.12. What is the ratio of the CO2 emissions (% of total fuel combustion) in 1963 in Luxembourg to that in Poland?
Offer a terse response. 0.09. What is the ratio of the CO2 emissions (% of total fuel combustion) in 1960 in Netherlands to that in New Zealand?
Offer a terse response. 1.05. What is the ratio of the CO2 emissions (% of total fuel combustion) of 1961 in Netherlands to that in New Zealand?
Your answer should be compact. 0.94. What is the ratio of the CO2 emissions (% of total fuel combustion) of 1962 in Netherlands to that in New Zealand?
Provide a short and direct response. 0.91. What is the ratio of the CO2 emissions (% of total fuel combustion) in 1963 in Netherlands to that in New Zealand?
Make the answer very short. 0.78. What is the ratio of the CO2 emissions (% of total fuel combustion) of 1960 in Netherlands to that in Norway?
Provide a short and direct response. 0.25. What is the ratio of the CO2 emissions (% of total fuel combustion) of 1961 in Netherlands to that in Norway?
Give a very brief answer. 0.24. What is the ratio of the CO2 emissions (% of total fuel combustion) in 1962 in Netherlands to that in Norway?
Provide a succinct answer. 0.24. What is the ratio of the CO2 emissions (% of total fuel combustion) in 1963 in Netherlands to that in Norway?
Your response must be concise. 0.24. What is the ratio of the CO2 emissions (% of total fuel combustion) of 1960 in Netherlands to that in Poland?
Your answer should be compact. 3.62. What is the ratio of the CO2 emissions (% of total fuel combustion) of 1961 in Netherlands to that in Poland?
Provide a succinct answer. 3.34. What is the ratio of the CO2 emissions (% of total fuel combustion) in 1962 in Netherlands to that in Poland?
Your response must be concise. 3.74. What is the ratio of the CO2 emissions (% of total fuel combustion) in 1963 in Netherlands to that in Poland?
Provide a succinct answer. 3. What is the ratio of the CO2 emissions (% of total fuel combustion) in 1960 in New Zealand to that in Norway?
Provide a succinct answer. 0.24. What is the ratio of the CO2 emissions (% of total fuel combustion) in 1961 in New Zealand to that in Norway?
Offer a very short reply. 0.26. What is the ratio of the CO2 emissions (% of total fuel combustion) in 1962 in New Zealand to that in Norway?
Offer a very short reply. 0.27. What is the ratio of the CO2 emissions (% of total fuel combustion) of 1963 in New Zealand to that in Norway?
Keep it short and to the point. 0.31. What is the ratio of the CO2 emissions (% of total fuel combustion) in 1960 in New Zealand to that in Poland?
Keep it short and to the point. 3.46. What is the ratio of the CO2 emissions (% of total fuel combustion) of 1961 in New Zealand to that in Poland?
Provide a succinct answer. 3.56. What is the ratio of the CO2 emissions (% of total fuel combustion) in 1962 in New Zealand to that in Poland?
Provide a succinct answer. 4.1. What is the ratio of the CO2 emissions (% of total fuel combustion) of 1963 in New Zealand to that in Poland?
Provide a short and direct response. 3.87. What is the ratio of the CO2 emissions (% of total fuel combustion) of 1960 in Norway to that in Poland?
Provide a short and direct response. 14.38. What is the ratio of the CO2 emissions (% of total fuel combustion) of 1961 in Norway to that in Poland?
Keep it short and to the point. 13.68. What is the ratio of the CO2 emissions (% of total fuel combustion) in 1962 in Norway to that in Poland?
Offer a terse response. 15.3. What is the ratio of the CO2 emissions (% of total fuel combustion) in 1963 in Norway to that in Poland?
Offer a terse response. 12.57. What is the difference between the highest and the second highest CO2 emissions (% of total fuel combustion) of 1960?
Make the answer very short. 16.93. What is the difference between the highest and the second highest CO2 emissions (% of total fuel combustion) of 1961?
Offer a very short reply. 16.09. What is the difference between the highest and the second highest CO2 emissions (% of total fuel combustion) of 1962?
Offer a very short reply. 16.13. What is the difference between the highest and the second highest CO2 emissions (% of total fuel combustion) of 1963?
Keep it short and to the point. 13.33. What is the difference between the highest and the lowest CO2 emissions (% of total fuel combustion) of 1960?
Your answer should be very brief. 22.45. What is the difference between the highest and the lowest CO2 emissions (% of total fuel combustion) in 1961?
Give a very brief answer. 21.63. What is the difference between the highest and the lowest CO2 emissions (% of total fuel combustion) of 1962?
Offer a terse response. 21.84. What is the difference between the highest and the lowest CO2 emissions (% of total fuel combustion) of 1963?
Your answer should be compact. 19.12. 